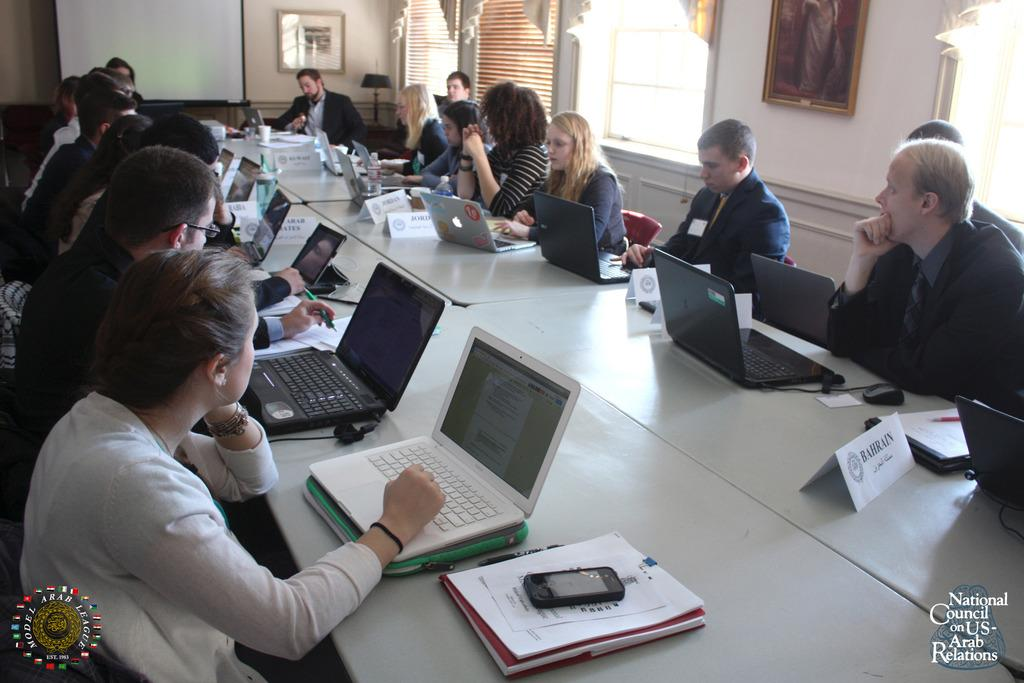<image>
Share a concise interpretation of the image provided. a group of workers on their laptops in Bahrain 